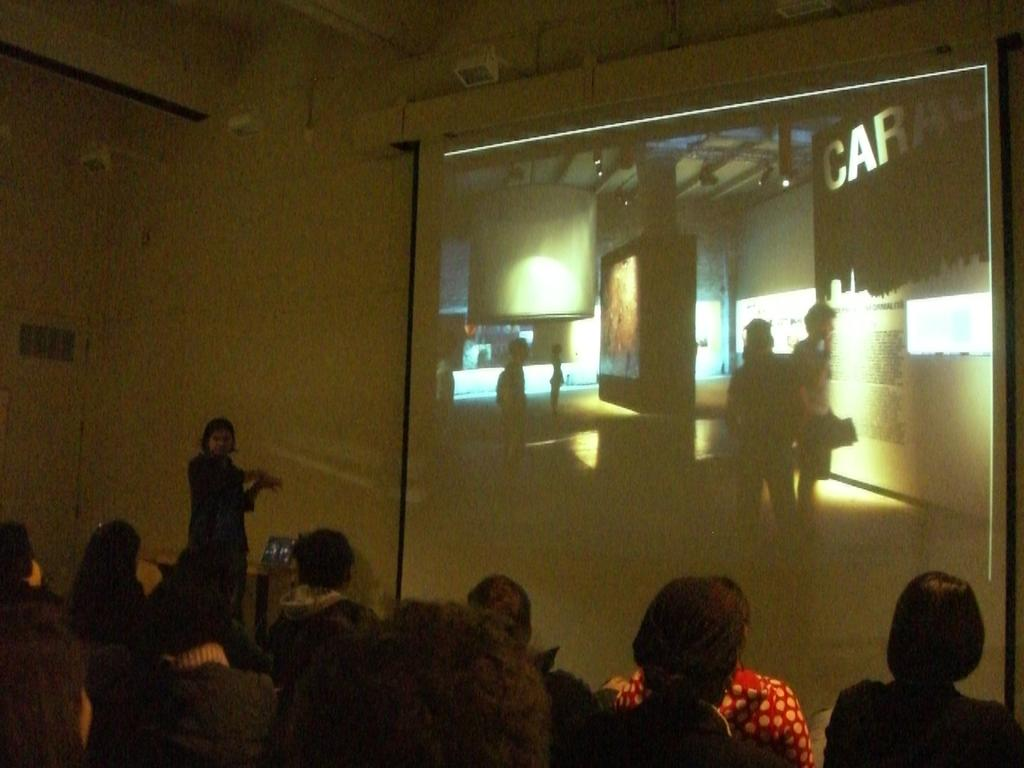What is the primary action of the person in the image? There is a person standing in the image. What are the other people in the image doing? There are people sitting in the image. What can be seen on the screen in the image? The facts do not specify what is on the screen, so we cannot answer that question definitively. What type of marble is being used to prepare the meal in the image? There is no mention of marble or a meal in the image, so we cannot answer that question. 